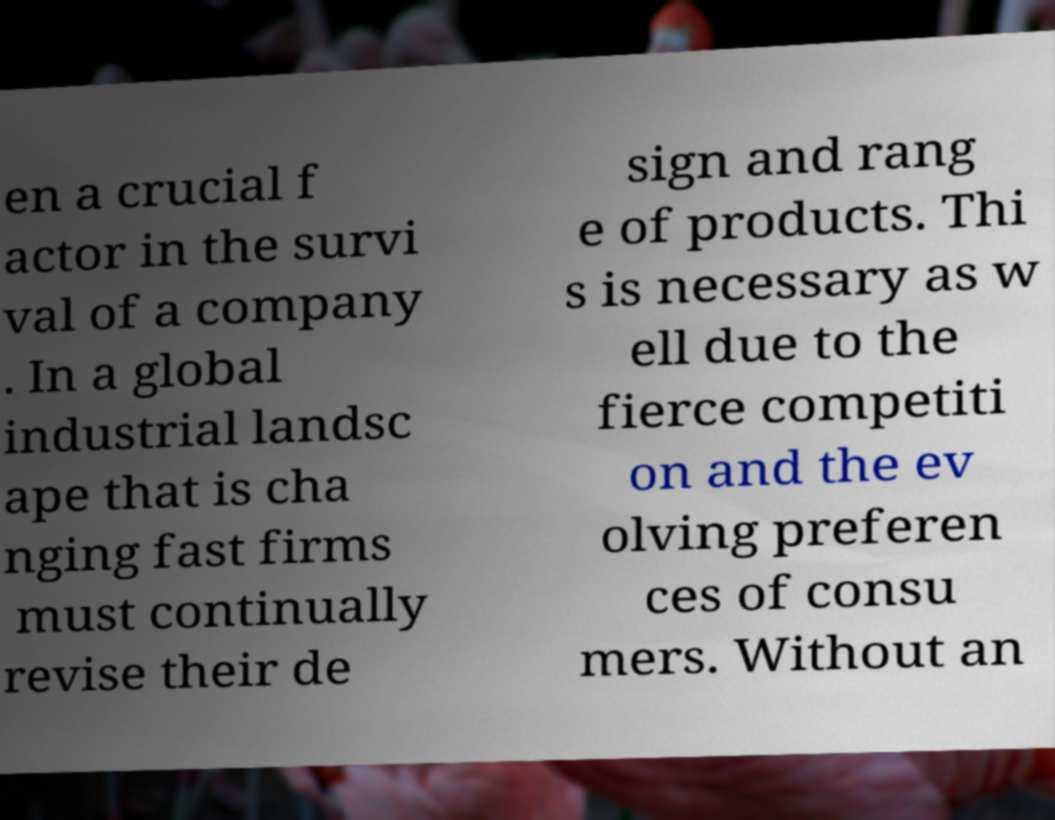I need the written content from this picture converted into text. Can you do that? en a crucial f actor in the survi val of a company . In a global industrial landsc ape that is cha nging fast firms must continually revise their de sign and rang e of products. Thi s is necessary as w ell due to the fierce competiti on and the ev olving preferen ces of consu mers. Without an 